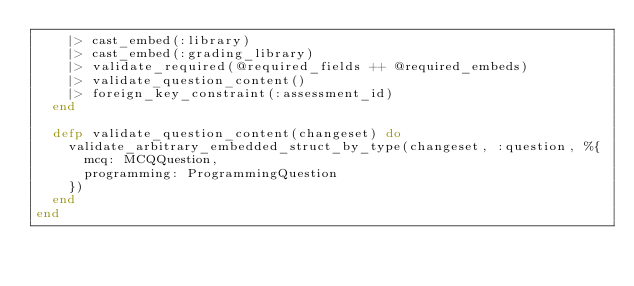Convert code to text. <code><loc_0><loc_0><loc_500><loc_500><_Elixir_>    |> cast_embed(:library)
    |> cast_embed(:grading_library)
    |> validate_required(@required_fields ++ @required_embeds)
    |> validate_question_content()
    |> foreign_key_constraint(:assessment_id)
  end

  defp validate_question_content(changeset) do
    validate_arbitrary_embedded_struct_by_type(changeset, :question, %{
      mcq: MCQQuestion,
      programming: ProgrammingQuestion
    })
  end
end
</code> 